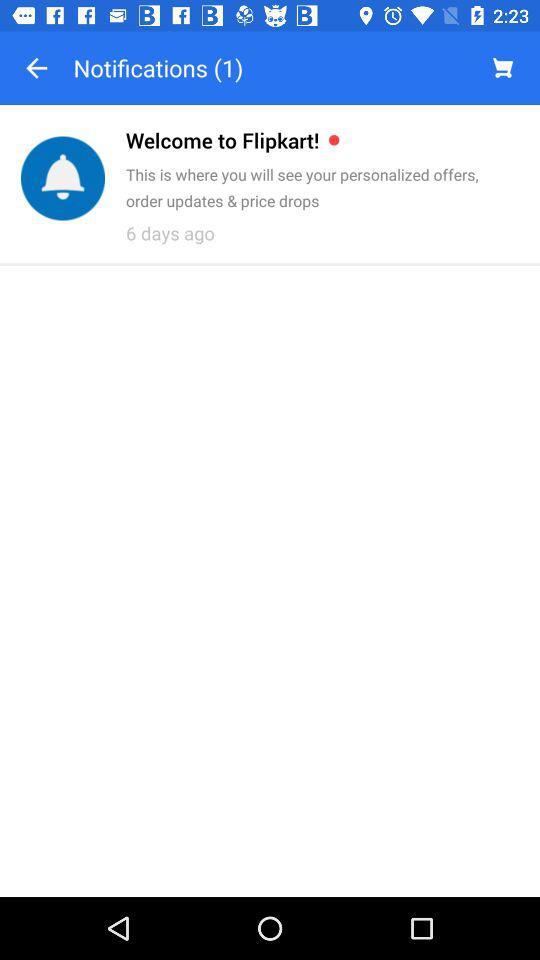When was the post posted? The post was posted 6 days ago. 